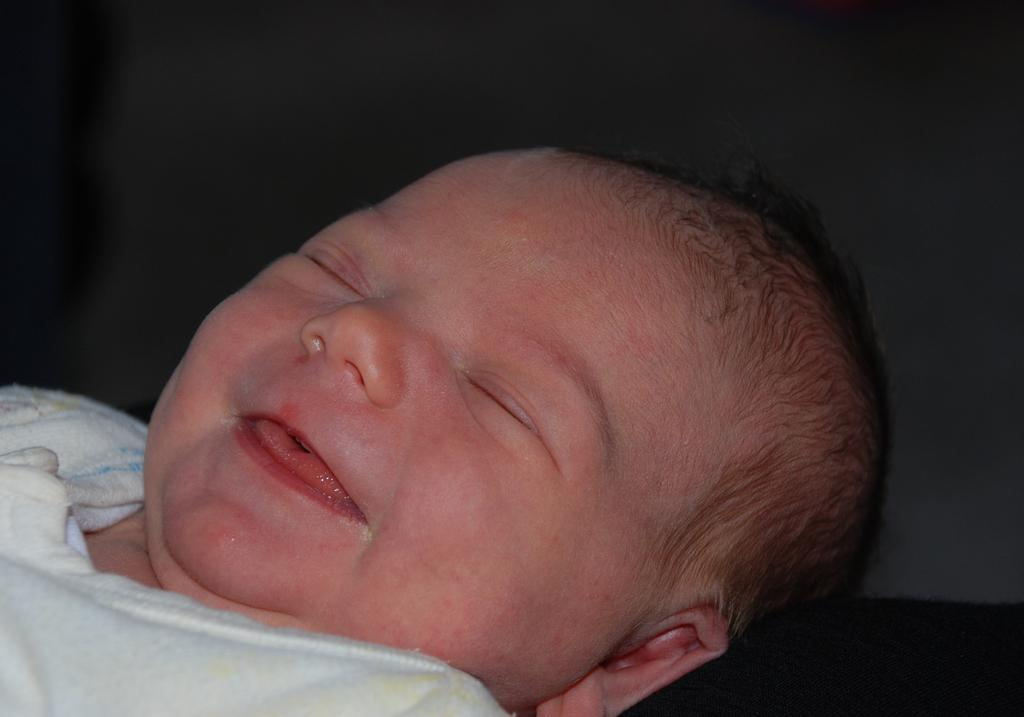What is the main subject of the image? The main subject of the image is a kid. What else can be seen in the image besides the kid? There is cloth in the image. Can you describe the background of the image? The background of the image is dark. What type of debt is the kid trying to pay off in the image? There is no indication of debt in the image; it features a kid and cloth with a dark background. What kind of notebook is the kid using to write in the image? There is no notebook present in the image. 